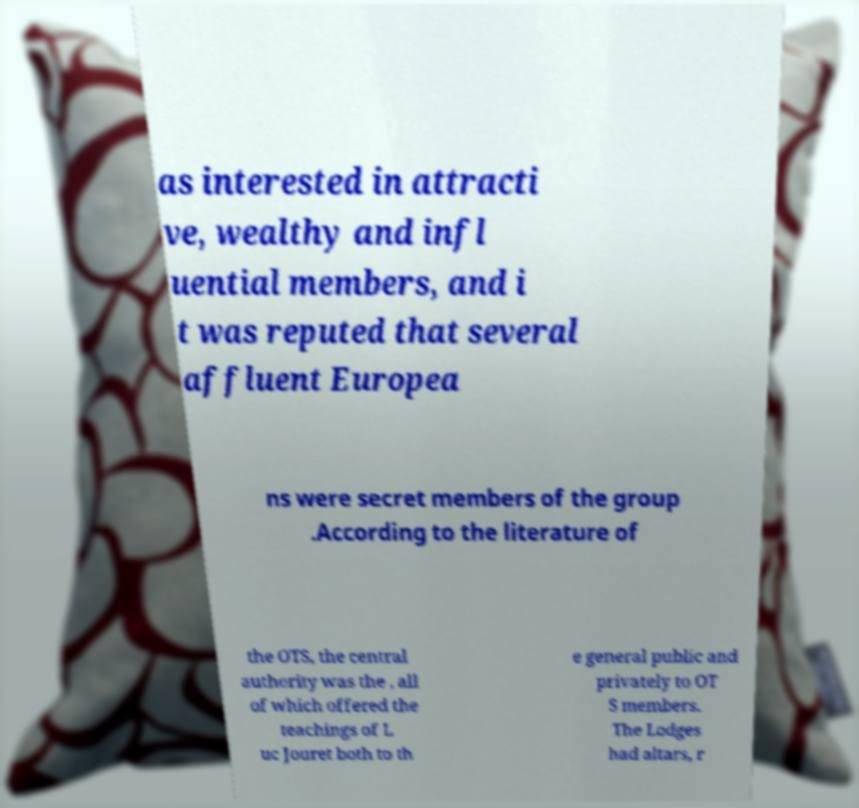Please read and relay the text visible in this image. What does it say? as interested in attracti ve, wealthy and infl uential members, and i t was reputed that several affluent Europea ns were secret members of the group .According to the literature of the OTS, the central authority was the , all of which offered the teachings of L uc Jouret both to th e general public and privately to OT S members. The Lodges had altars, r 